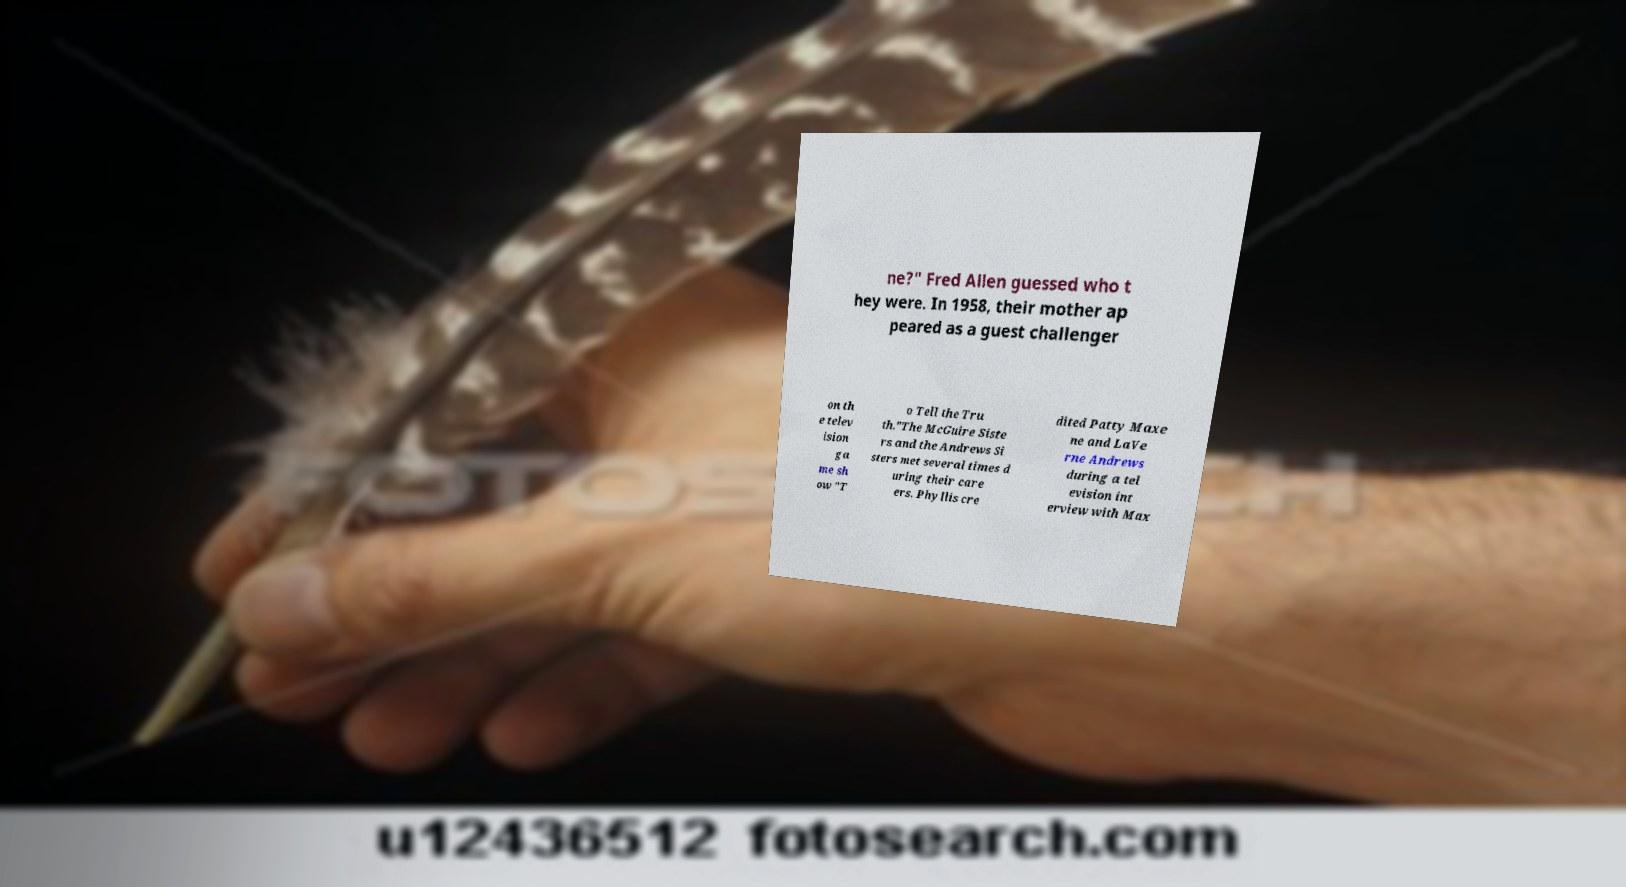Can you read and provide the text displayed in the image?This photo seems to have some interesting text. Can you extract and type it out for me? ne?" Fred Allen guessed who t hey were. In 1958, their mother ap peared as a guest challenger on th e telev ision ga me sh ow "T o Tell the Tru th."The McGuire Siste rs and the Andrews Si sters met several times d uring their care ers. Phyllis cre dited Patty Maxe ne and LaVe rne Andrews during a tel evision int erview with Max 